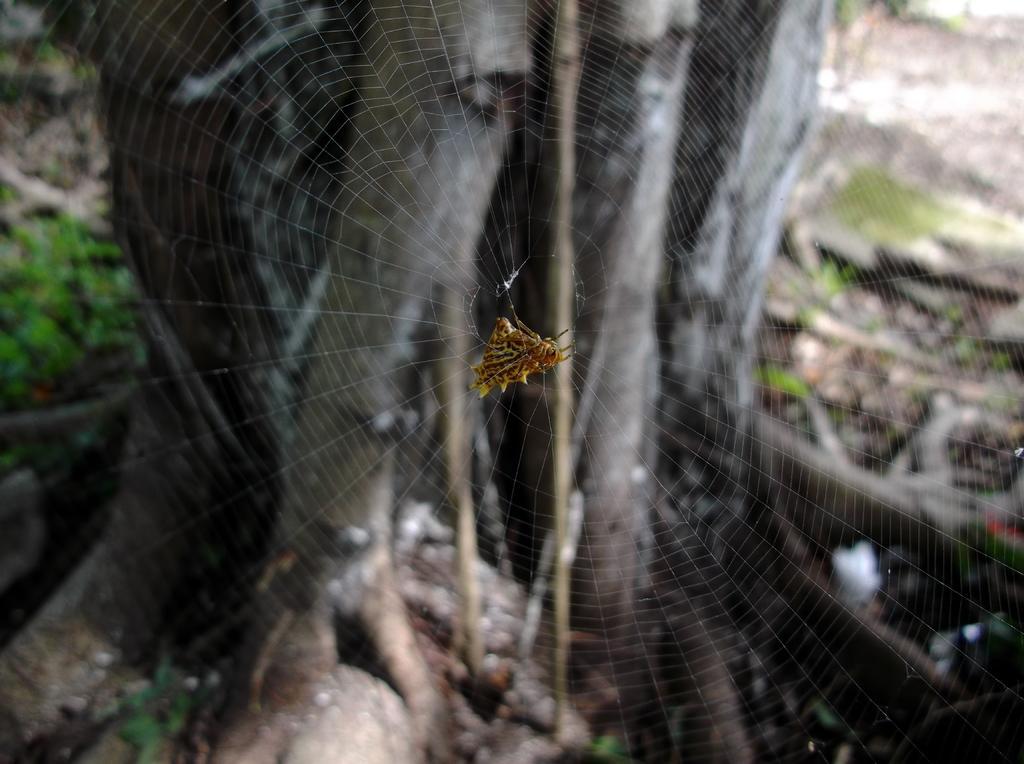Could you give a brief overview of what you see in this image? In the picture I can see a spider on a spider web. In the background I can see a tree and grass. 